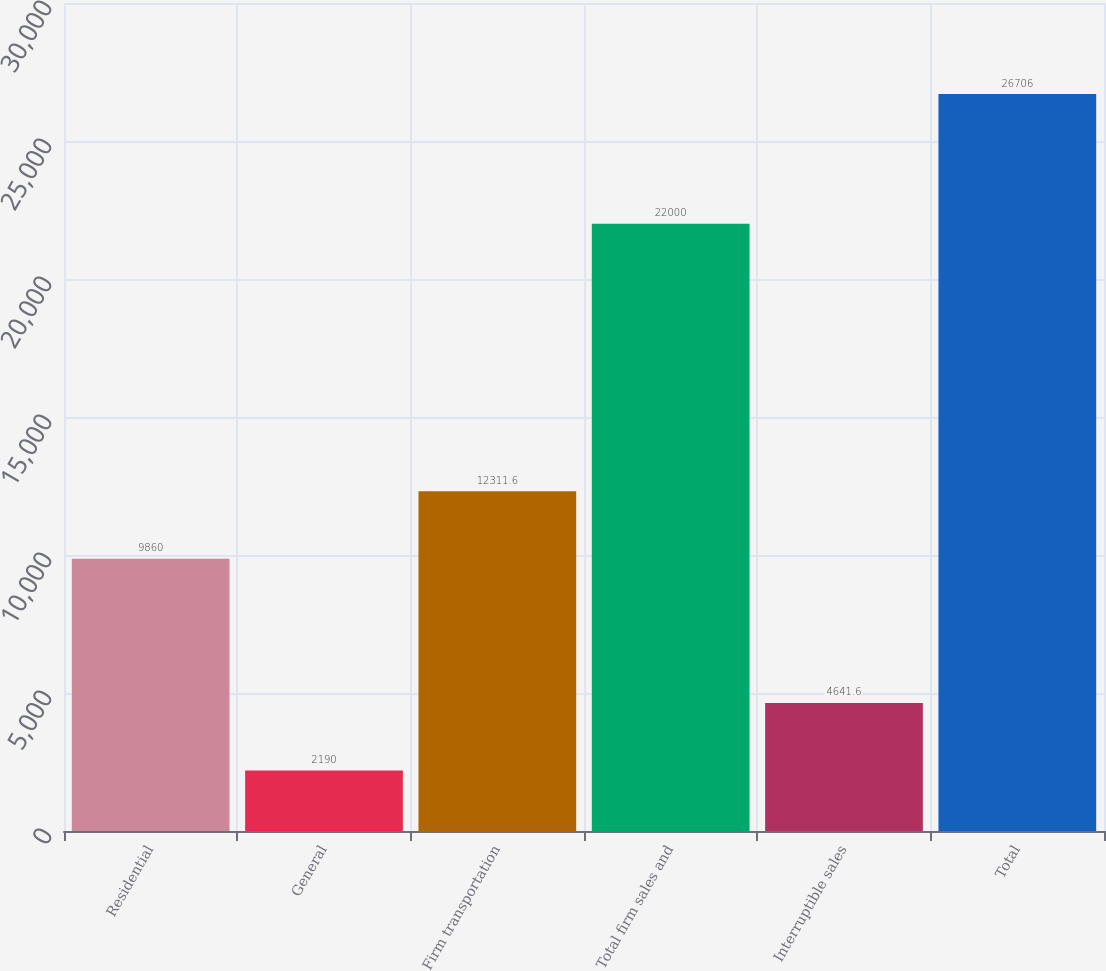Convert chart to OTSL. <chart><loc_0><loc_0><loc_500><loc_500><bar_chart><fcel>Residential<fcel>General<fcel>Firm transportation<fcel>Total firm sales and<fcel>Interruptible sales<fcel>Total<nl><fcel>9860<fcel>2190<fcel>12311.6<fcel>22000<fcel>4641.6<fcel>26706<nl></chart> 